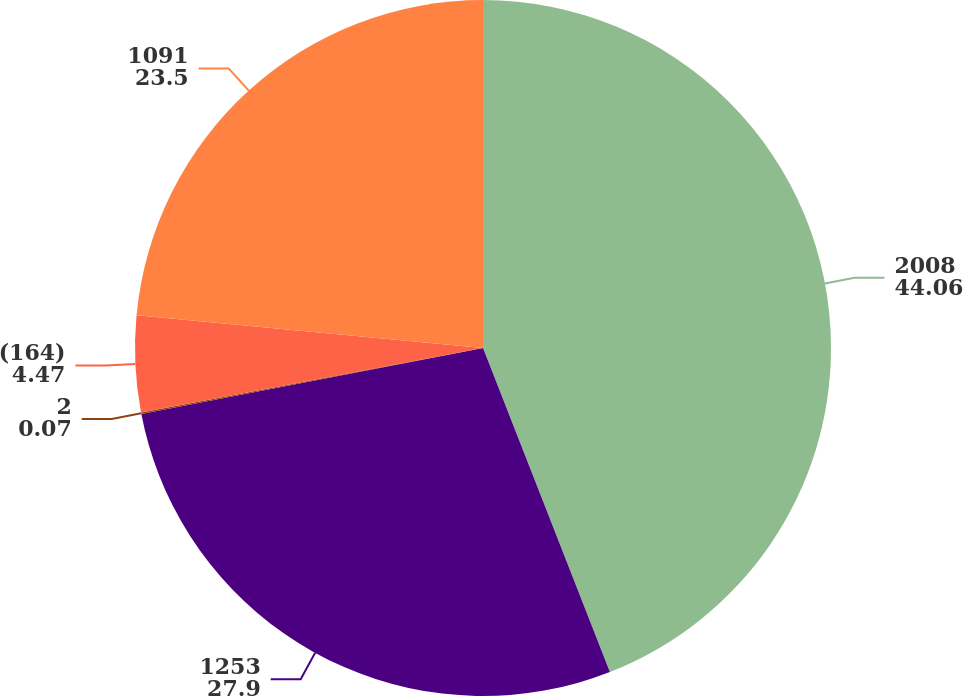Convert chart. <chart><loc_0><loc_0><loc_500><loc_500><pie_chart><fcel>2008<fcel>1253<fcel>2<fcel>(164)<fcel>1091<nl><fcel>44.06%<fcel>27.9%<fcel>0.07%<fcel>4.47%<fcel>23.5%<nl></chart> 